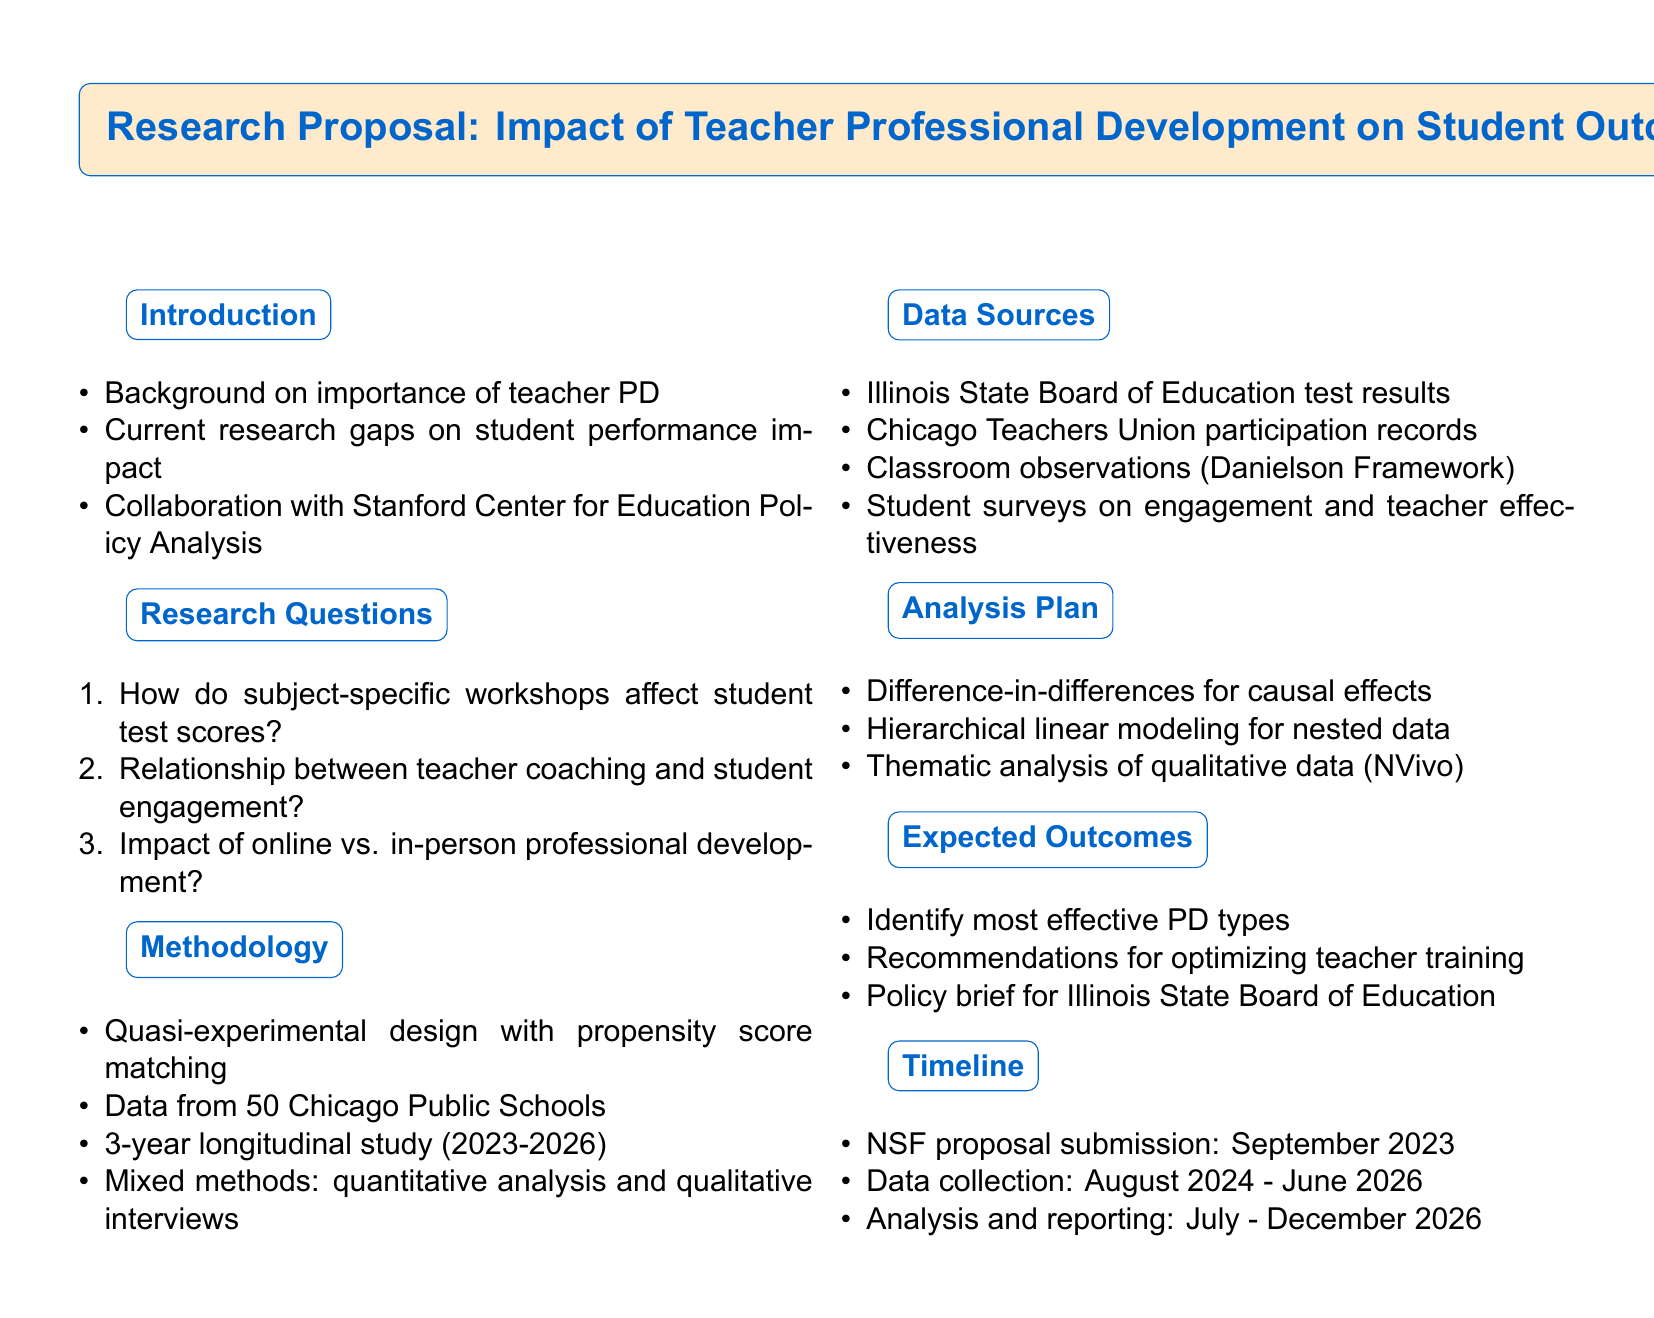What is the title of the research proposal? The title of the research proposal outlines the main focus of the study, which is on the impact of teacher professional development on student outcomes.
Answer: Impact of Teacher Professional Development on Student Outcomes How many schools will be involved in the data collection? The document states that data will be collected from 50 schools in the Chicago Public Schools district.
Answer: 50 schools What is one of the research questions about teacher coaching? The document lists several research questions, one of which specifically focuses on the relationship between teacher coaching programs and student engagement.
Answer: Relationship between teacher coaching programs and student engagement What type of study design is being used? The methodology section mentions that a quasi-experimental design will be utilized, specifically using propensity score matching.
Answer: Quasi-experimental design What software will be used for qualitative data analysis? The analysis plan indicates that NVivo software will be employed for thematic analysis of qualitative data.
Answer: NVivo When is the proposal submission to the National Science Foundation planned? The timeline section provides specific dates, indicating that the proposal submission is scheduled for September 2023.
Answer: September 2023 What is the duration of the longitudinal study? According to the methodology, the longitudinal study will span over three academic years, specifically from 2023 to 2026.
Answer: 3 years What outcomes are expected from the research? The expected outcomes section outlines several results, including identification of the most effective types of professional development.
Answer: Identification of most effective types of professional development 